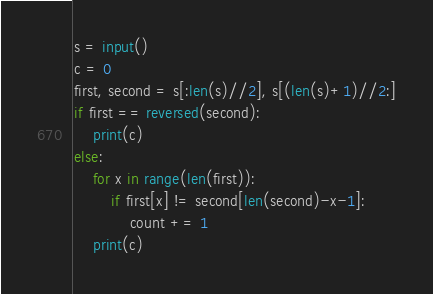<code> <loc_0><loc_0><loc_500><loc_500><_Python_>s = input()
c = 0
first, second = s[:len(s)//2], s[(len(s)+1)//2:]
if first == reversed(second):
    print(c)
else:
    for x in range(len(first)):
        if first[x] != second[len(second)-x-1]:
            count += 1
    print(c)</code> 